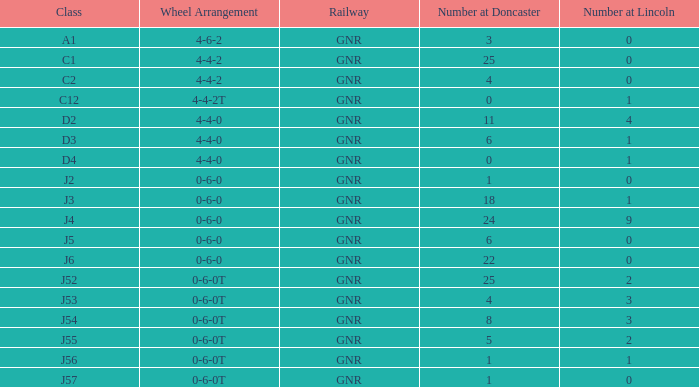Which class has a number greater than 0 at lincoln and a number of 8 at doncaster? J54. 